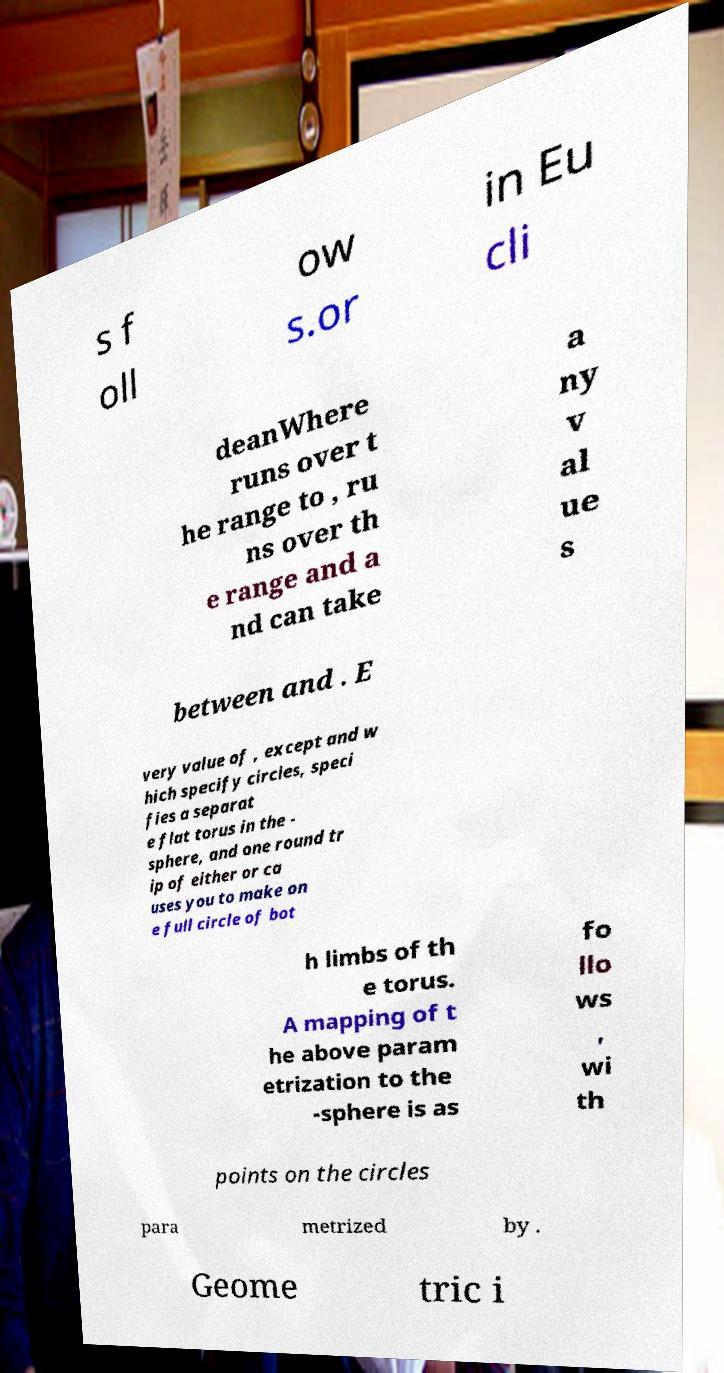There's text embedded in this image that I need extracted. Can you transcribe it verbatim? s f oll ow s.or in Eu cli deanWhere runs over t he range to , ru ns over th e range and a nd can take a ny v al ue s between and . E very value of , except and w hich specify circles, speci fies a separat e flat torus in the - sphere, and one round tr ip of either or ca uses you to make on e full circle of bot h limbs of th e torus. A mapping of t he above param etrization to the -sphere is as fo llo ws , wi th points on the circles para metrized by . Geome tric i 